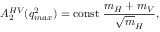Convert formula to latex. <formula><loc_0><loc_0><loc_500><loc_500>A _ { 2 } ^ { H V } ( q _ { \max } ^ { 2 } ) = c o n s t \frac { m _ { H } + m _ { V } } { { \sqrt { m } _ { H } } } ,</formula> 